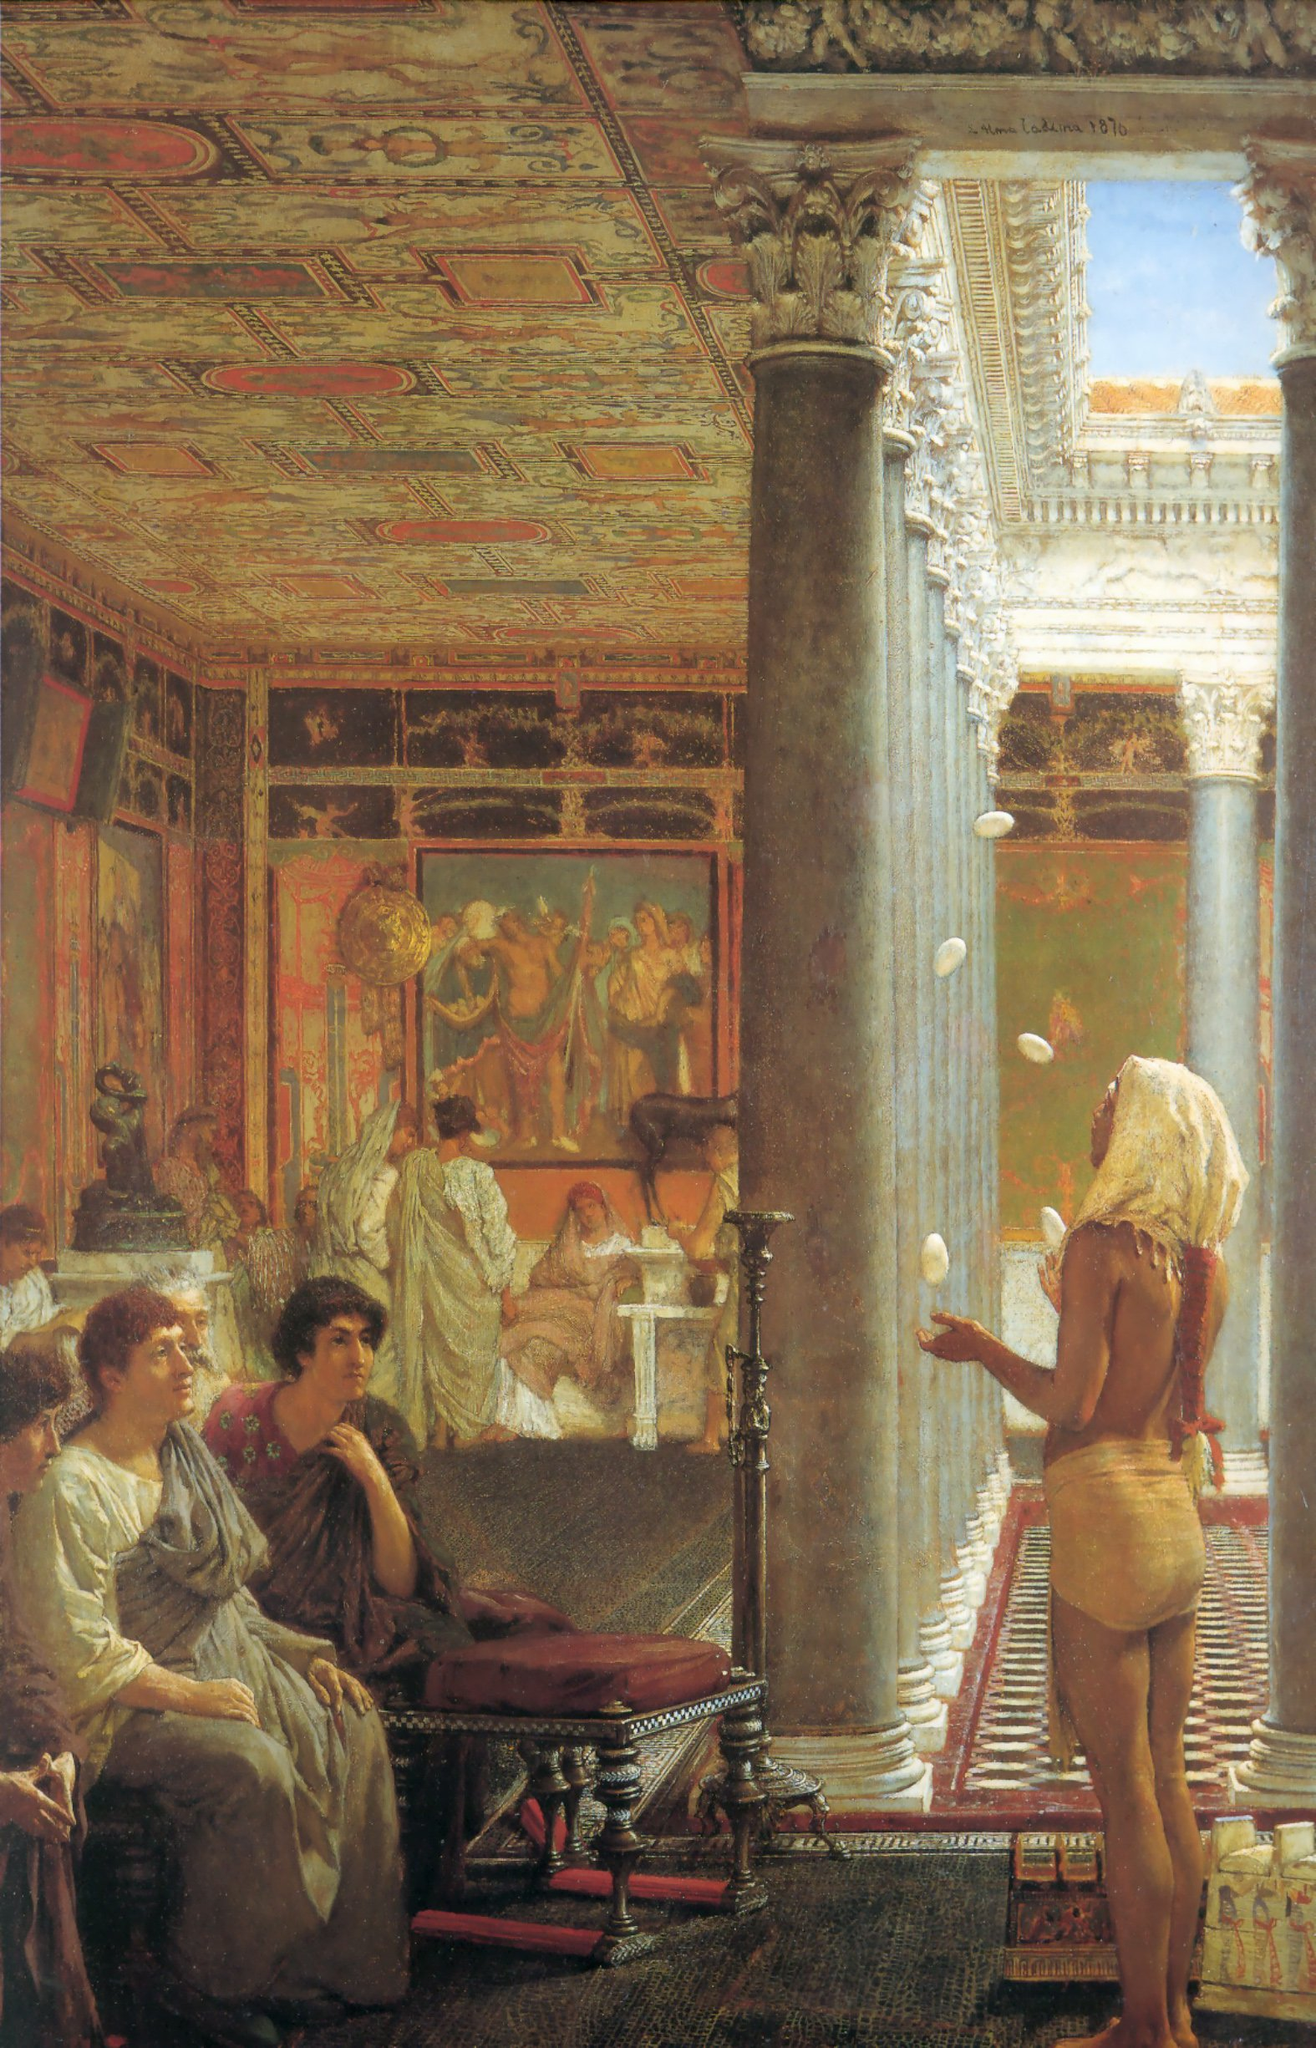What are the key elements in this picture? The painting captures an opulent setting within a grandiose room adorned with classical art and elaborate decorations. The high ceilings and extensive architectural details, such as ornate columns and richly decorated surfaces, emphasize the luxuriance of the environment. The scene revolves around a central figure of a woman in a flowing white dress, positioned in front of a large window, drawing immediate attention. The palette features warm, opulent colors like gold, red, and shades of cream, enhancing the historical and classical aura. The various figures, dressed in period-appropriate attire, contribute to the composition's historical narrative, giving it a timeless and detailed quality that encapsulates a moment of refined elegance and cultural richness. 